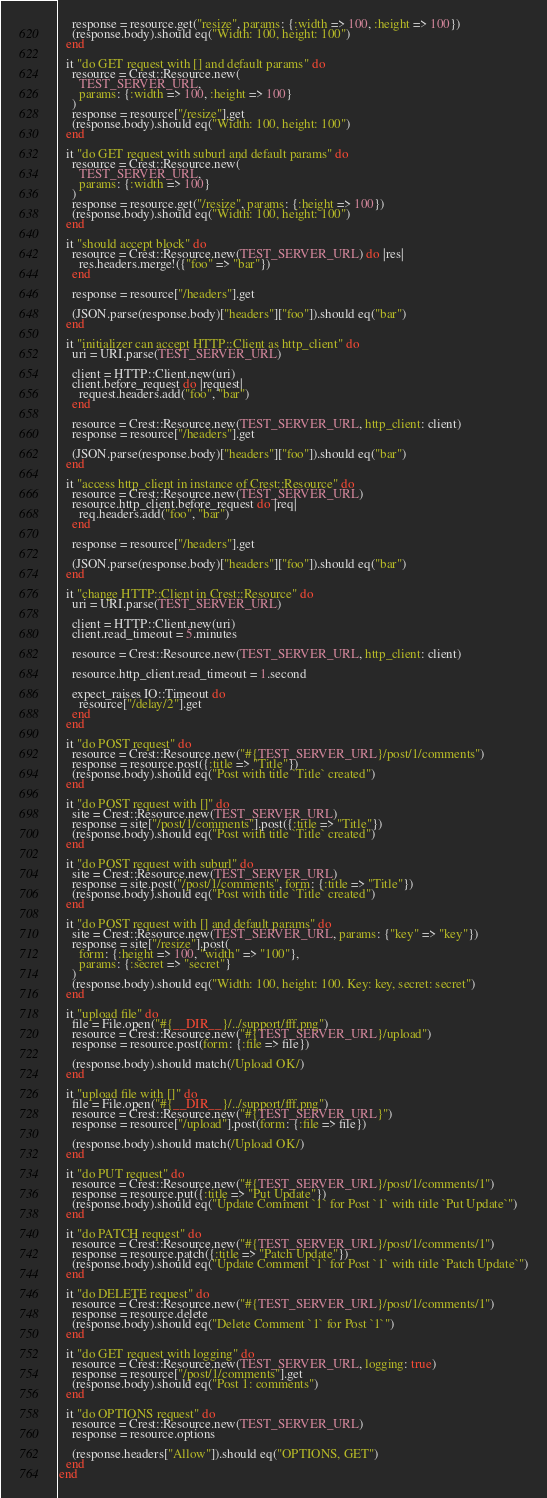<code> <loc_0><loc_0><loc_500><loc_500><_Crystal_>    response = resource.get("resize", params: {:width => 100, :height => 100})
    (response.body).should eq("Width: 100, height: 100")
  end

  it "do GET request with [] and default params" do
    resource = Crest::Resource.new(
      TEST_SERVER_URL,
      params: {:width => 100, :height => 100}
    )
    response = resource["/resize"].get
    (response.body).should eq("Width: 100, height: 100")
  end

  it "do GET request with suburl and default params" do
    resource = Crest::Resource.new(
      TEST_SERVER_URL,
      params: {:width => 100}
    )
    response = resource.get("/resize", params: {:height => 100})
    (response.body).should eq("Width: 100, height: 100")
  end

  it "should accept block" do
    resource = Crest::Resource.new(TEST_SERVER_URL) do |res|
      res.headers.merge!({"foo" => "bar"})
    end

    response = resource["/headers"].get

    (JSON.parse(response.body)["headers"]["foo"]).should eq("bar")
  end

  it "initializer can accept HTTP::Client as http_client" do
    uri = URI.parse(TEST_SERVER_URL)

    client = HTTP::Client.new(uri)
    client.before_request do |request|
      request.headers.add("foo", "bar")
    end

    resource = Crest::Resource.new(TEST_SERVER_URL, http_client: client)
    response = resource["/headers"].get

    (JSON.parse(response.body)["headers"]["foo"]).should eq("bar")
  end

  it "access http_client in instance of Crest::Resource" do
    resource = Crest::Resource.new(TEST_SERVER_URL)
    resource.http_client.before_request do |req|
      req.headers.add("foo", "bar")
    end

    response = resource["/headers"].get

    (JSON.parse(response.body)["headers"]["foo"]).should eq("bar")
  end

  it "change HTTP::Client in Crest::Resource" do
    uri = URI.parse(TEST_SERVER_URL)

    client = HTTP::Client.new(uri)
    client.read_timeout = 5.minutes

    resource = Crest::Resource.new(TEST_SERVER_URL, http_client: client)

    resource.http_client.read_timeout = 1.second

    expect_raises IO::Timeout do
      resource["/delay/2"].get
    end
  end

  it "do POST request" do
    resource = Crest::Resource.new("#{TEST_SERVER_URL}/post/1/comments")
    response = resource.post({:title => "Title"})
    (response.body).should eq("Post with title `Title` created")
  end

  it "do POST request with []" do
    site = Crest::Resource.new(TEST_SERVER_URL)
    response = site["/post/1/comments"].post({:title => "Title"})
    (response.body).should eq("Post with title `Title` created")
  end

  it "do POST request with suburl" do
    site = Crest::Resource.new(TEST_SERVER_URL)
    response = site.post("/post/1/comments", form: {:title => "Title"})
    (response.body).should eq("Post with title `Title` created")
  end

  it "do POST request with [] and default params" do
    site = Crest::Resource.new(TEST_SERVER_URL, params: {"key" => "key"})
    response = site["/resize"].post(
      form: {:height => 100, "width" => "100"},
      params: {:secret => "secret"}
    )
    (response.body).should eq("Width: 100, height: 100. Key: key, secret: secret")
  end

  it "upload file" do
    file = File.open("#{__DIR__}/../support/fff.png")
    resource = Crest::Resource.new("#{TEST_SERVER_URL}/upload")
    response = resource.post(form: {:file => file})

    (response.body).should match(/Upload OK/)
  end

  it "upload file with []" do
    file = File.open("#{__DIR__}/../support/fff.png")
    resource = Crest::Resource.new("#{TEST_SERVER_URL}")
    response = resource["/upload"].post(form: {:file => file})

    (response.body).should match(/Upload OK/)
  end

  it "do PUT request" do
    resource = Crest::Resource.new("#{TEST_SERVER_URL}/post/1/comments/1")
    response = resource.put({:title => "Put Update"})
    (response.body).should eq("Update Comment `1` for Post `1` with title `Put Update`")
  end

  it "do PATCH request" do
    resource = Crest::Resource.new("#{TEST_SERVER_URL}/post/1/comments/1")
    response = resource.patch({:title => "Patch Update"})
    (response.body).should eq("Update Comment `1` for Post `1` with title `Patch Update`")
  end

  it "do DELETE request" do
    resource = Crest::Resource.new("#{TEST_SERVER_URL}/post/1/comments/1")
    response = resource.delete
    (response.body).should eq("Delete Comment `1` for Post `1`")
  end

  it "do GET request with logging" do
    resource = Crest::Resource.new(TEST_SERVER_URL, logging: true)
    response = resource["/post/1/comments"].get
    (response.body).should eq("Post 1: comments")
  end

  it "do OPTIONS request" do
    resource = Crest::Resource.new(TEST_SERVER_URL)
    response = resource.options

    (response.headers["Allow"]).should eq("OPTIONS, GET")
  end
end
</code> 